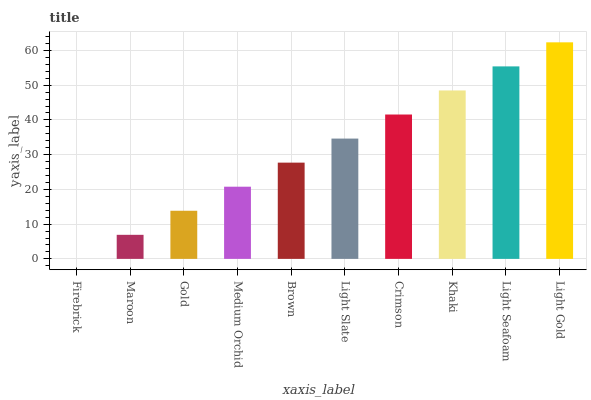Is Firebrick the minimum?
Answer yes or no. Yes. Is Light Gold the maximum?
Answer yes or no. Yes. Is Maroon the minimum?
Answer yes or no. No. Is Maroon the maximum?
Answer yes or no. No. Is Maroon greater than Firebrick?
Answer yes or no. Yes. Is Firebrick less than Maroon?
Answer yes or no. Yes. Is Firebrick greater than Maroon?
Answer yes or no. No. Is Maroon less than Firebrick?
Answer yes or no. No. Is Light Slate the high median?
Answer yes or no. Yes. Is Brown the low median?
Answer yes or no. Yes. Is Khaki the high median?
Answer yes or no. No. Is Gold the low median?
Answer yes or no. No. 